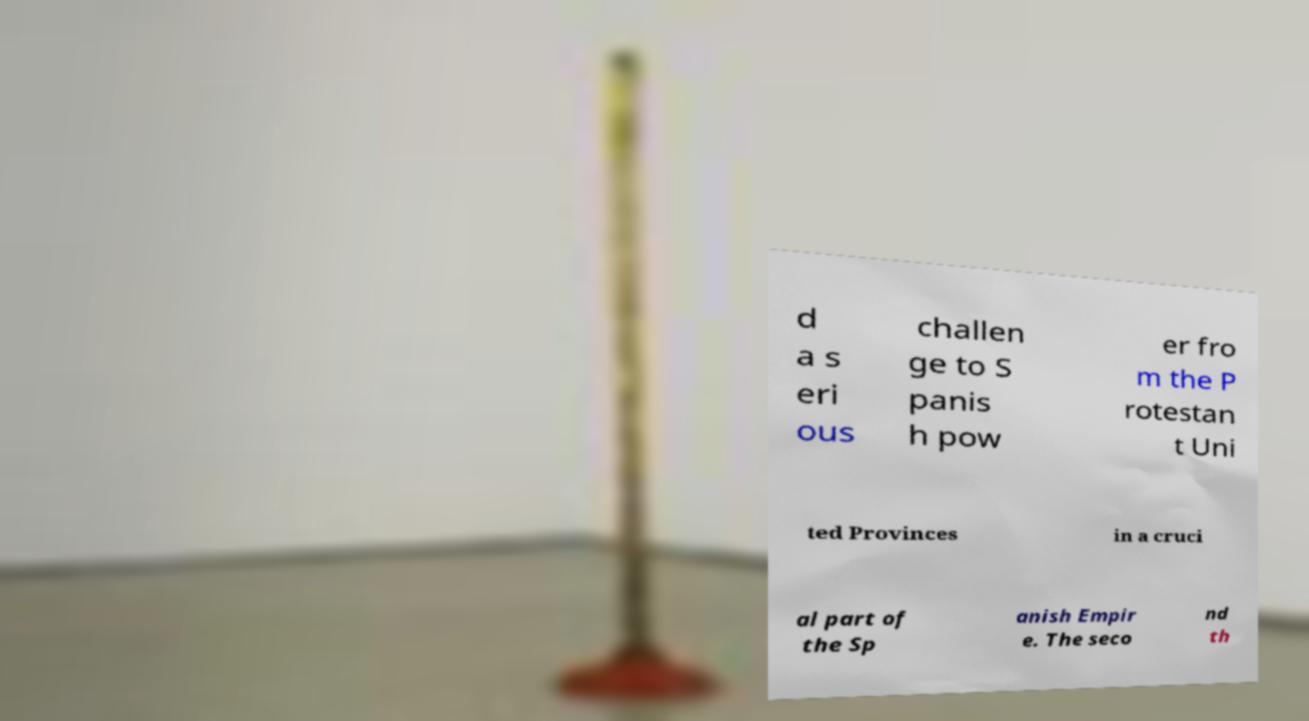Can you read and provide the text displayed in the image?This photo seems to have some interesting text. Can you extract and type it out for me? d a s eri ous challen ge to S panis h pow er fro m the P rotestan t Uni ted Provinces in a cruci al part of the Sp anish Empir e. The seco nd th 